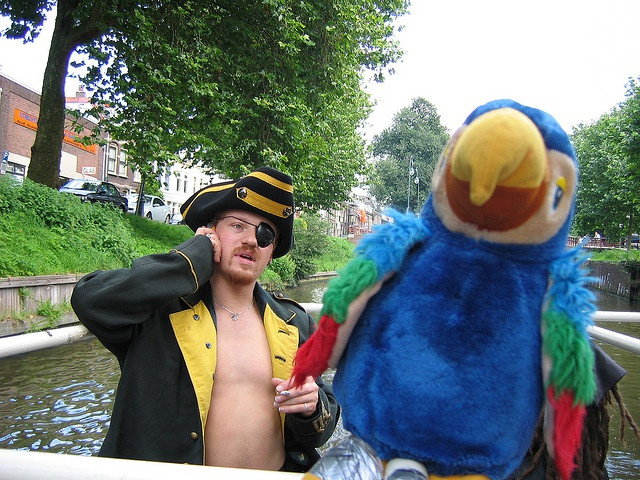Describe the objects in this image and their specific colors. I can see people in gray, black, lightpink, and khaki tones, car in gray, black, white, and blue tones, car in gray, white, lightblue, black, and darkgray tones, car in gray, white, black, and darkgray tones, and cell phone in gray, black, blue, maroon, and white tones in this image. 